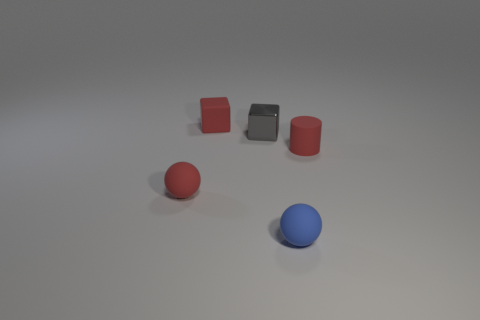Add 4 cubes. How many objects exist? 9 Subtract all cubes. How many objects are left? 3 Add 4 small red cylinders. How many small red cylinders exist? 5 Subtract 0 green balls. How many objects are left? 5 Subtract all tiny purple rubber objects. Subtract all small gray metallic objects. How many objects are left? 4 Add 1 metal things. How many metal things are left? 2 